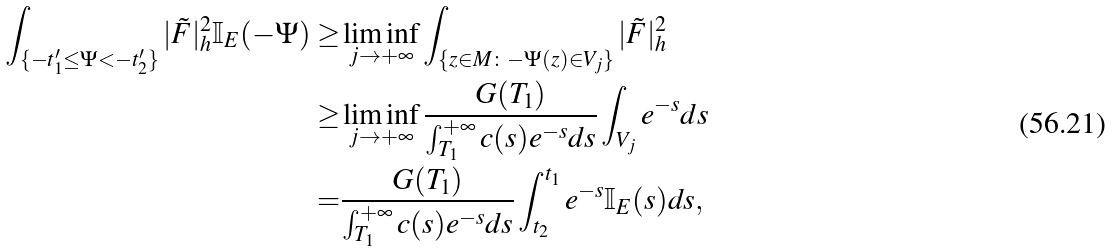<formula> <loc_0><loc_0><loc_500><loc_500>\int _ { \{ - t ^ { \prime } _ { 1 } \leq \Psi < - t ^ { \prime } _ { 2 } \} } | \tilde { F } | ^ { 2 } _ { h } \mathbb { I } _ { E } ( - \Psi ) \geq & \liminf _ { j \to + \infty } \int _ { \{ z \in M \colon - \Psi ( z ) \in V _ { j } \} } | \tilde { F } | ^ { 2 } _ { h } \\ \geq & \liminf _ { j \to + \infty } \frac { G ( T _ { 1 } ) } { \int _ { T _ { 1 } } ^ { + \infty } c ( s ) e ^ { - s } d s } \int _ { V _ { j } } e ^ { - s } d s \\ = & \frac { G ( T _ { 1 } ) } { \int _ { T _ { 1 } } ^ { + \infty } c ( s ) e ^ { - s } d s } \int _ { t _ { 2 } } ^ { t _ { 1 } } e ^ { - s } \mathbb { I } _ { E } ( s ) d s ,</formula> 